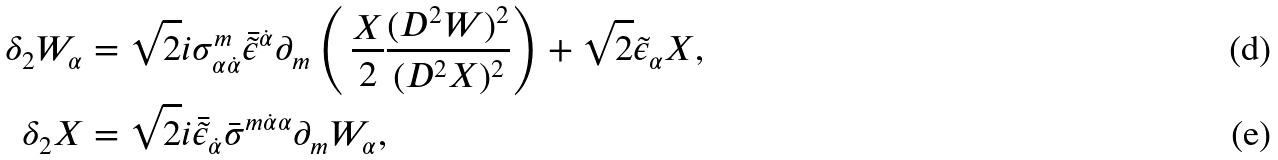Convert formula to latex. <formula><loc_0><loc_0><loc_500><loc_500>\delta _ { 2 } W _ { \alpha } & = \sqrt { 2 } i \sigma _ { \alpha \dot { \alpha } } ^ { m } \bar { \tilde { \epsilon } } ^ { \dot { \alpha } } \partial _ { m } \left ( \, \frac { X } { 2 } \frac { ( D ^ { 2 } W ) ^ { 2 } } { ( D ^ { 2 } X ) ^ { 2 } } \right ) + \sqrt { 2 } \tilde { \epsilon } _ { \alpha } X , \\ \delta _ { 2 } X & = \sqrt { 2 } i \bar { \tilde { \epsilon } } _ { \dot { \alpha } } \bar { \sigma } ^ { m \dot { \alpha } \alpha } \partial _ { m } W _ { \alpha } ,</formula> 